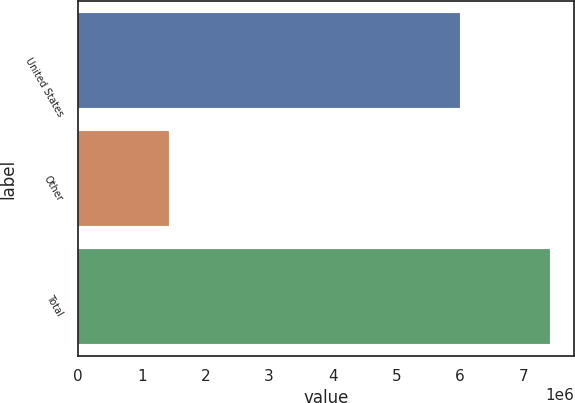<chart> <loc_0><loc_0><loc_500><loc_500><bar_chart><fcel>United States<fcel>Other<fcel>Total<nl><fcel>5.99656e+06<fcel>1.4252e+06<fcel>7.42177e+06<nl></chart> 